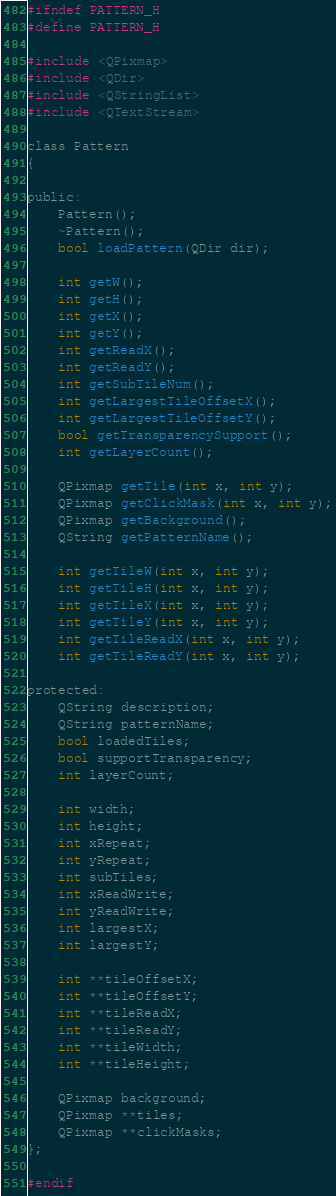Convert code to text. <code><loc_0><loc_0><loc_500><loc_500><_C_>#ifndef PATTERN_H
#define PATTERN_H

#include <QPixmap>
#include <QDir>
#include <QStringList>
#include <QTextStream>

class Pattern
{

public:
	Pattern();
	~Pattern();
	bool loadPattern(QDir dir);
	
	int getW();
	int getH();
	int getX();
	int getY();
	int getReadX();
	int getReadY();
	int getSubTileNum();
	int getLargestTileOffsetX();
	int getLargestTileOffsetY();
	bool getTransparencySupport();
	int getLayerCount();

	QPixmap getTile(int x, int y);
	QPixmap getClickMask(int x, int y);
	QPixmap getBackground();
	QString getPatternName();

	int getTileW(int x, int y);
	int getTileH(int x, int y);
	int getTileX(int x, int y);
	int getTileY(int x, int y);
	int getTileReadX(int x, int y);
	int getTileReadY(int x, int y);

protected:
	QString description;
	QString patternName;
	bool loadedTiles;
	bool supportTransparency;
	int layerCount;

	int width;
	int height;
	int xRepeat;
	int yRepeat;
	int subTiles;
	int xReadWrite;
	int yReadWrite;
	int largestX;
	int largestY;

	int **tileOffsetX;
	int **tileOffsetY;
	int **tileReadX;
	int **tileReadY;
	int **tileWidth;
	int **tileHeight;

	QPixmap background;
	QPixmap **tiles;
	QPixmap **clickMasks;
};

#endif
</code> 